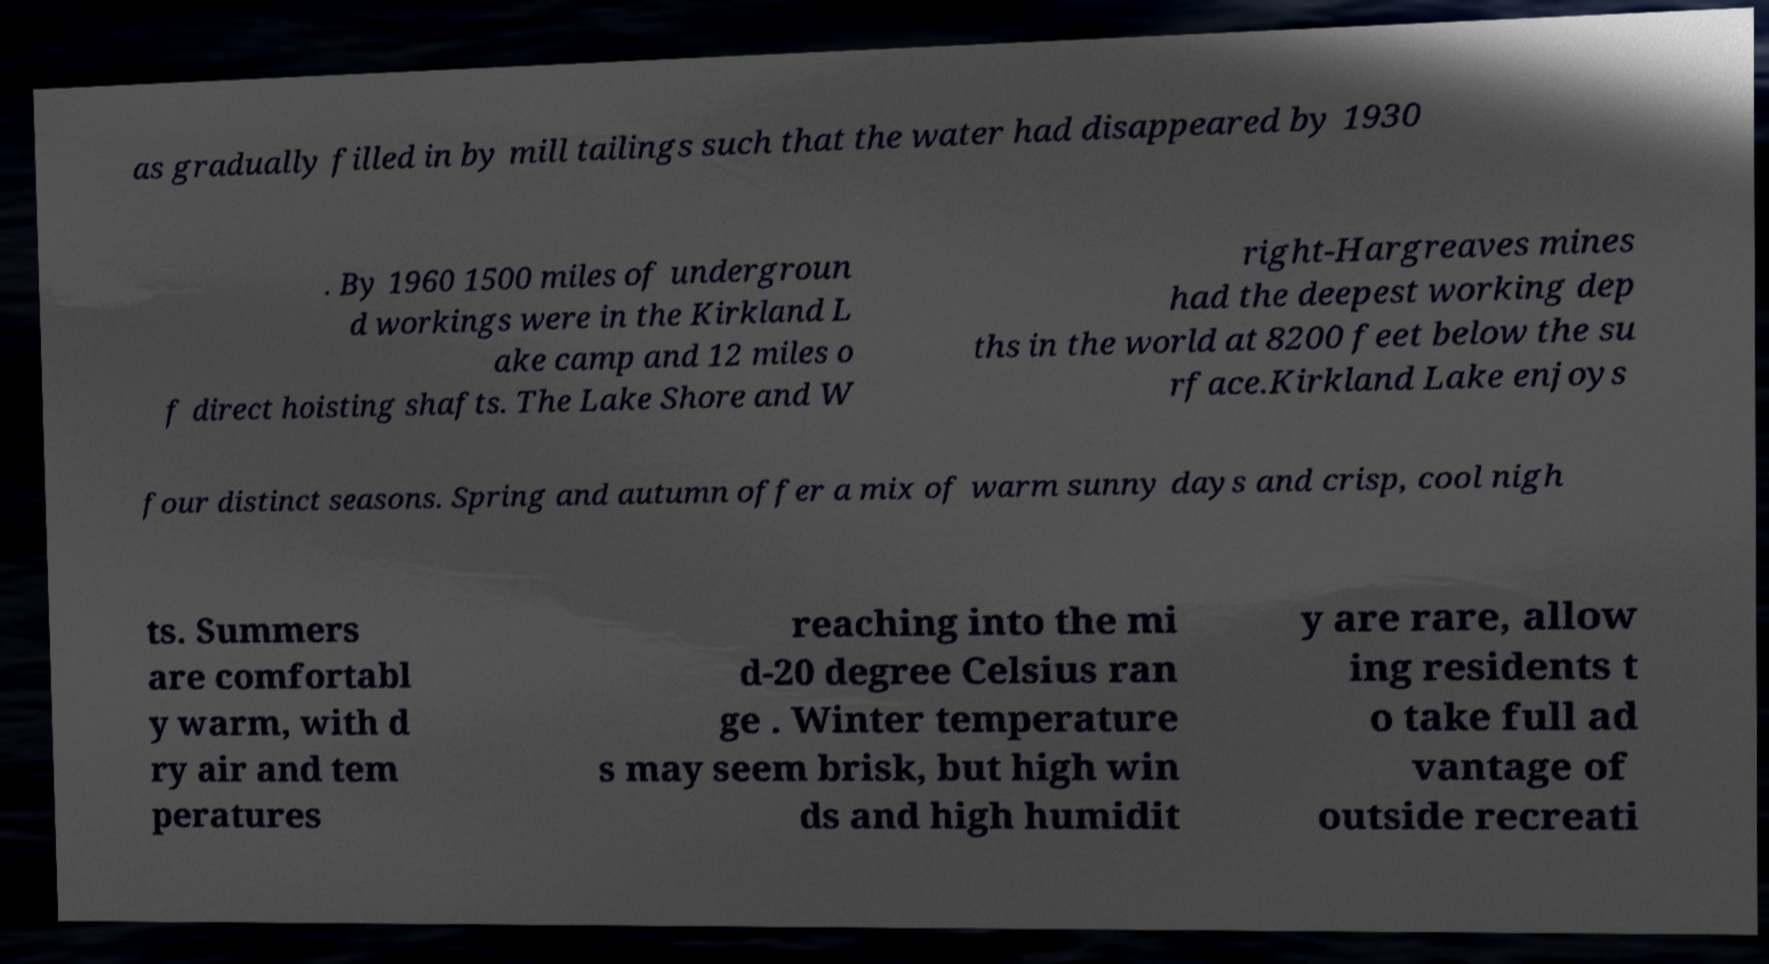Please identify and transcribe the text found in this image. as gradually filled in by mill tailings such that the water had disappeared by 1930 . By 1960 1500 miles of undergroun d workings were in the Kirkland L ake camp and 12 miles o f direct hoisting shafts. The Lake Shore and W right-Hargreaves mines had the deepest working dep ths in the world at 8200 feet below the su rface.Kirkland Lake enjoys four distinct seasons. Spring and autumn offer a mix of warm sunny days and crisp, cool nigh ts. Summers are comfortabl y warm, with d ry air and tem peratures reaching into the mi d-20 degree Celsius ran ge . Winter temperature s may seem brisk, but high win ds and high humidit y are rare, allow ing residents t o take full ad vantage of outside recreati 